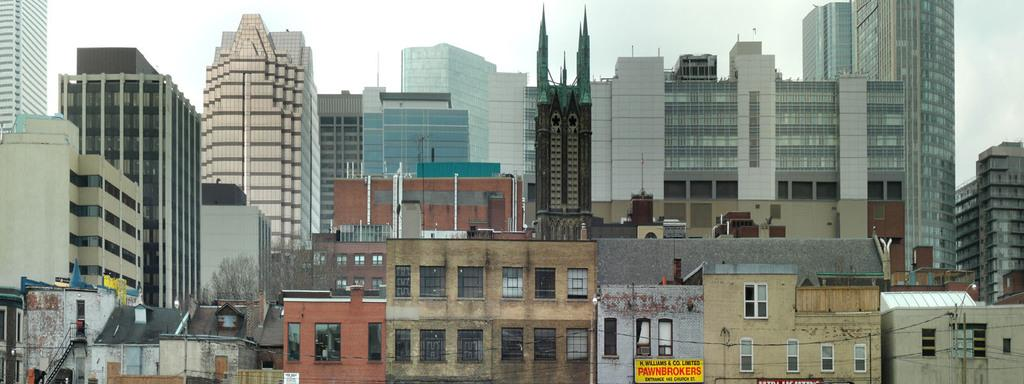<image>
Give a short and clear explanation of the subsequent image. Among a building landscape is a yellow sign for K. Williams & Co. Limited Pawnbrokers. 